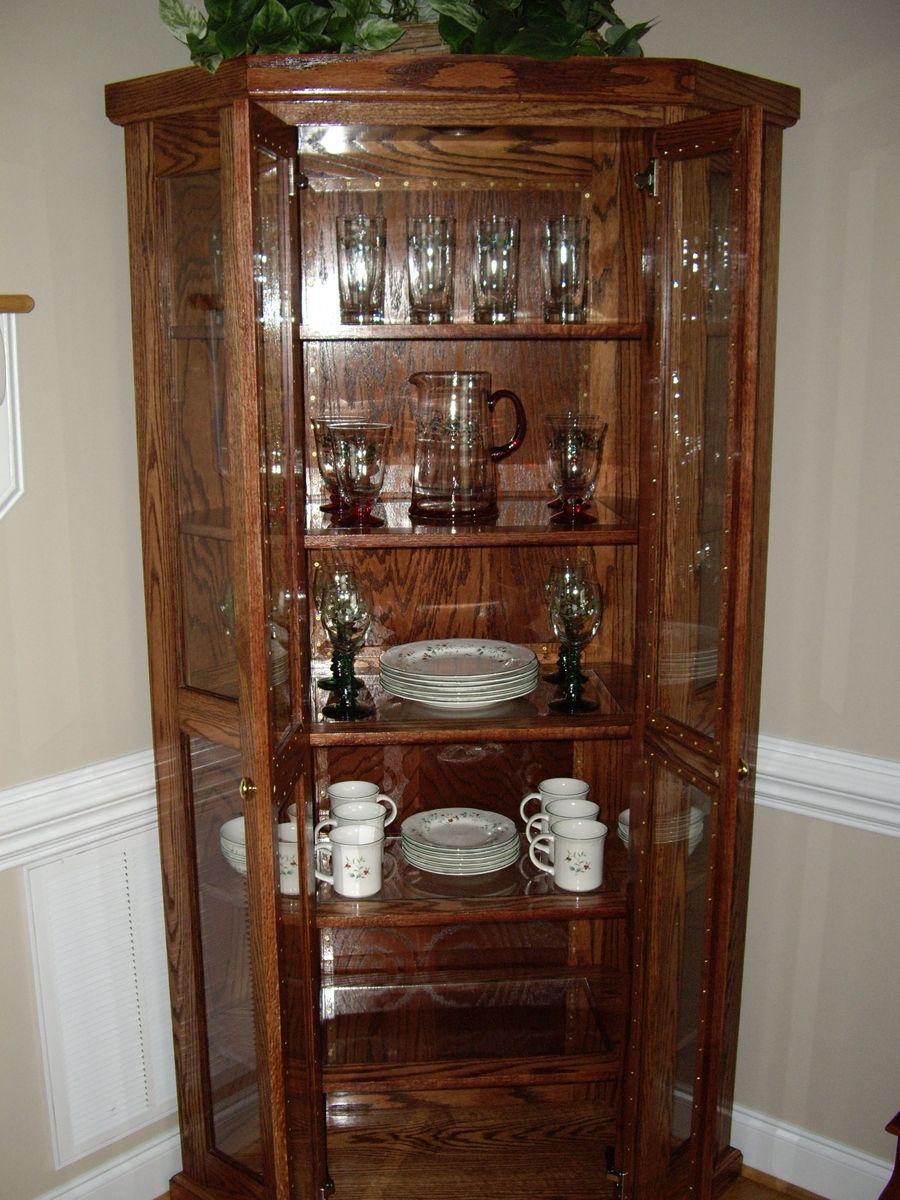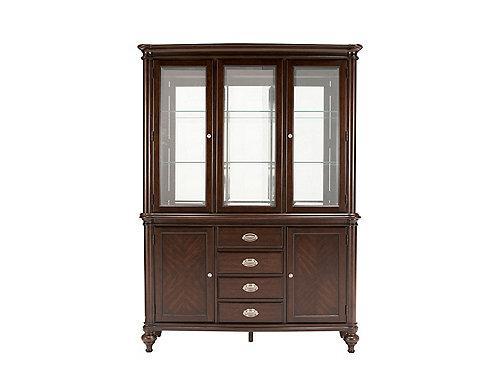The first image is the image on the left, the second image is the image on the right. Examine the images to the left and right. Is the description "One of the cabinets is empty." accurate? Answer yes or no. Yes. 